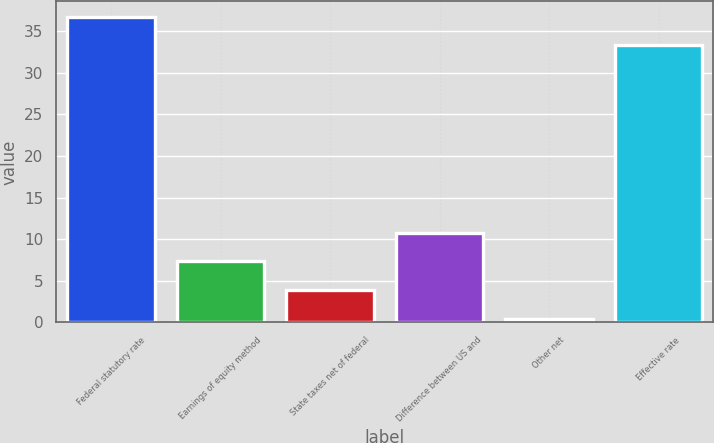Convert chart. <chart><loc_0><loc_0><loc_500><loc_500><bar_chart><fcel>Federal statutory rate<fcel>Earnings of equity method<fcel>State taxes net of federal<fcel>Difference between US and<fcel>Other net<fcel>Effective rate<nl><fcel>36.76<fcel>7.32<fcel>3.86<fcel>10.78<fcel>0.4<fcel>33.3<nl></chart> 